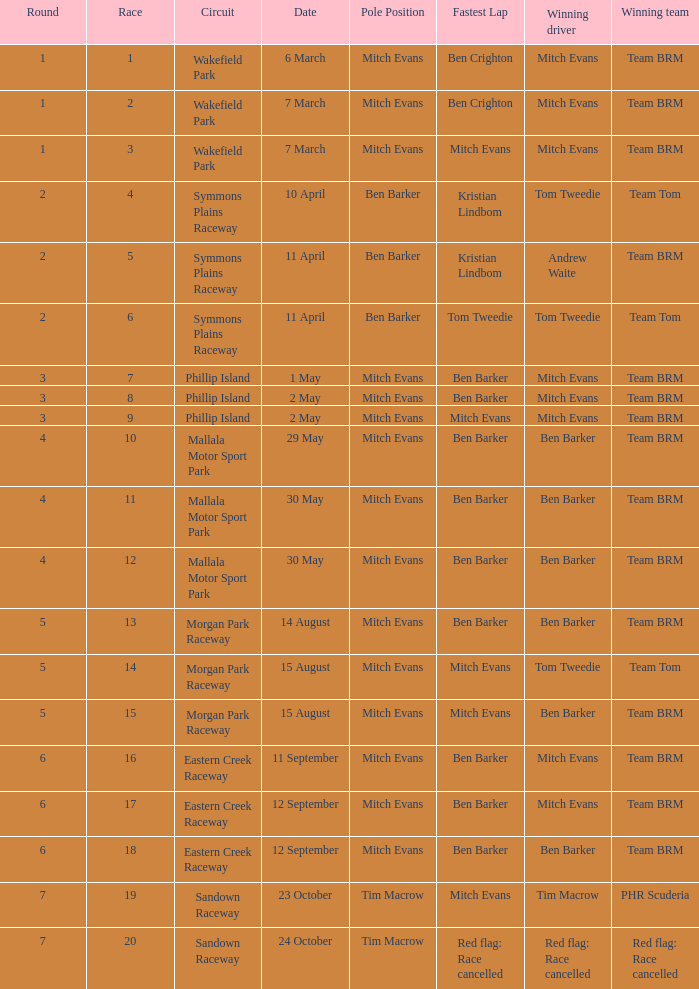How many rounds were there in race 17? 1.0. 